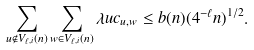Convert formula to latex. <formula><loc_0><loc_0><loc_500><loc_500>\sum _ { u \notin V _ { \ell , i } ( n ) } \sum _ { w \in V _ { \ell , i } ( n ) } \lambda u c _ { u , w } \leq b ( n ) ( 4 ^ { - \ell } n ) ^ { 1 / 2 } .</formula> 